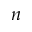<formula> <loc_0><loc_0><loc_500><loc_500>n</formula> 